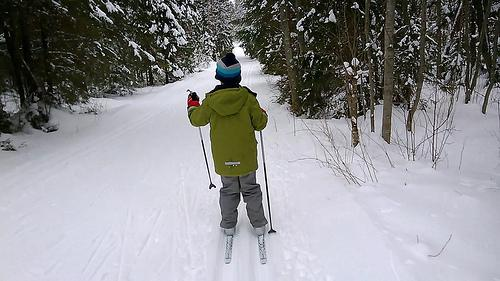Question: what color is the ground?
Choices:
A. Green.
B. Black.
C. White.
D. Brown.
Answer with the letter. Answer: C Question: why is the ground white?
Choices:
A. It's covered in clouds.
B. It's foggy.
C. It's rain.
D. It's covered in snow.
Answer with the letter. Answer: D Question: what color jacket does the skier have?
Choices:
A. Yellow.
B. Green.
C. White.
D. Red.
Answer with the letter. Answer: B Question: what color gloves does the skier have?
Choices:
A. Lavender and pink.
B. Many colors.
C. Red and black.
D. Taupe.
Answer with the letter. Answer: C Question: what color pants is the skier wearing?
Choices:
A. White.
B. Gray.
C. Green.
D. Blue.
Answer with the letter. Answer: B 